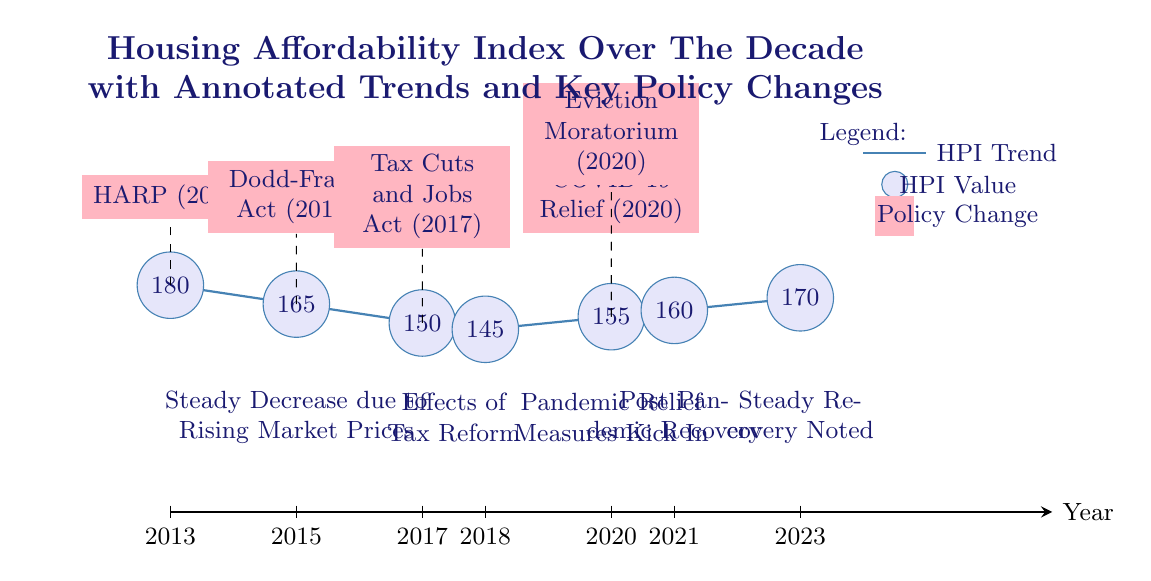What year was the Tax Cuts and Jobs Act implemented? The Tax Cuts and Jobs Act is labeled in the diagram as occurring in the year 2017, which is indicated by the relevant node positioned at x=4.
Answer: 2017 What is the value of the Housing Price Index at 2021? The value of the Housing Price Index in 2021 is represented by the node at x=8, which is at the point y=3.2. The value is annotated next to the node as 160.
Answer: 160 What is the highest Housing Price Index value recorded in the diagram? The diagram shows various points plotted, with the highest value occurring in 2013, at y=3.6, with an annotation indicating its value as 180 next to the corresponding node.
Answer: 180 What do the dashed lines represent in the diagram? The dashed lines connect the Housing Price Index values to their respective policy changes and illustrate the relationship or impact of each policy on the index.
Answer: Policy impact Which year marks the start of the pandemic relief measures noted in the diagram? The diagram indicates that the pandemic relief measures began in 2020, as shown at x=7, near the annotations related to these measures.
Answer: 2020 What does the steady decrease in the Housing Price Index from 2013 to 2015 illustrate? The diagram includes an annotation specifying a "Steady Decrease due to Rising Market Prices" between the years 2013 and 2015, implying that increasing prices negatively affected the affordability index during this period.
Answer: Market Prices How many key policy changes are noted in the diagram? The diagram lists five distinct key policy changes indicated by colored rectangles placed at various points along the timeline, specifically for the years 2013, 2015, 2017, and 2020.
Answer: Five What is indicated by the year 2023 in terms of Housing Price Index recovery? The annotation positioned at x=10 indicates a "Steady Recovery Noted," implying that by 2023, there is an established improvement in the Housing Price Index compared to previous years.
Answer: Steady Recovery What was the effect of the Eviction Moratorium according to the diagram? The Eviction Moratorium is connected with a dashed line to the index's value at y=3.1 in 2020, suggesting a protective effect on affordability during the pandemic, as indicated by the annotations.
Answer: Protective effect 